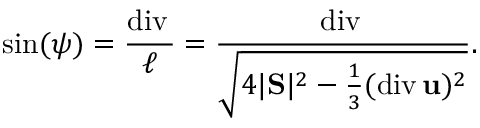Convert formula to latex. <formula><loc_0><loc_0><loc_500><loc_500>\sin ( \psi ) = \frac { d i v \, \ u } { \ell } = \frac { d i v \, \ u } { \sqrt { 4 | S | ^ { 2 } - \frac { 1 } { 3 } ( d i v \, { u } ) ^ { 2 } } } .</formula> 